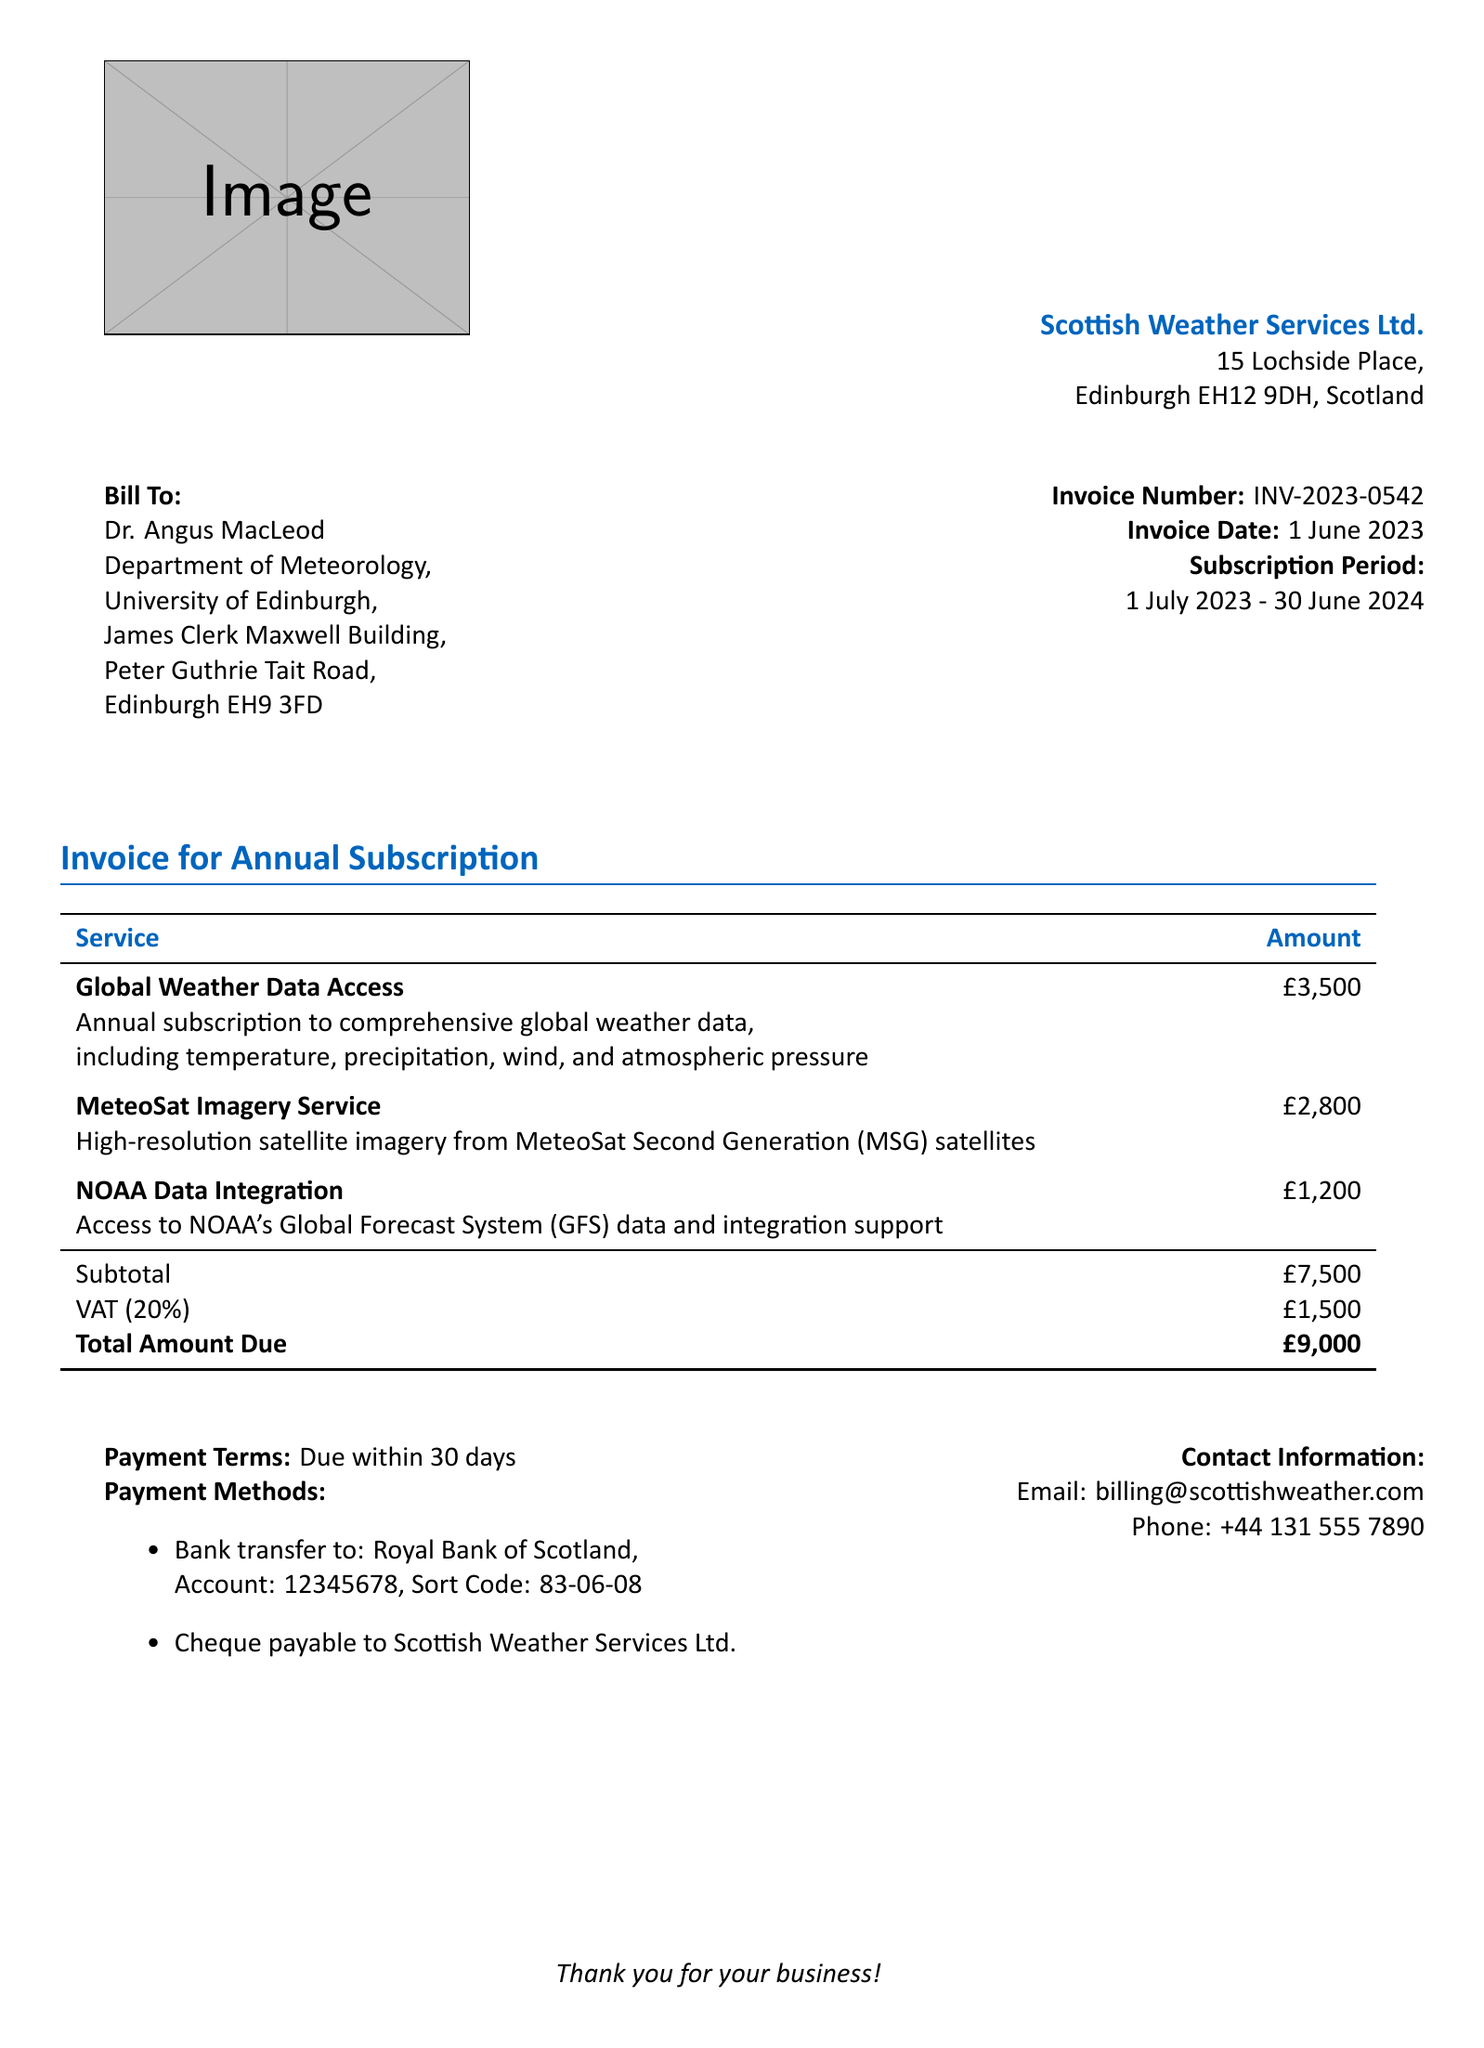What is the invoice number? The invoice number is a specific identifier for the bill, found in the document.
Answer: INV-2023-0542 Who is the bill addressed to? The bill lists the recipient's name and affiliation, which is crucial for invoicing.
Answer: Dr. Angus MacLeod What is the total amount due? This is the final charge that must be paid, including any taxes and fees, as indicated in the document.
Answer: £9,000 What is the VAT percentage? This percentage shows the value-added tax applied to the subtotal, necessary for understanding the total cost.
Answer: 20% What services are included in the annual subscription? This question helps to identify the specific services that the subscriber is paying for, which are listed in the document.
Answer: Global Weather Data Access, MeteoSat Imagery Service, NOAA Data Integration When is the payment due? The payment terms provide information on when the payment must be completed, which is essential for fiscal planning.
Answer: 30 days What is the subtotal amount before VAT? This is the total cost of services before tax is added, reflecting the base price for the subscription.
Answer: £7,500 What are the payment methods? Knowing the payment methods is essential for processing the payment, as the document outlines various options.
Answer: Bank transfer, Cheque Where is Scottish Weather Services Ltd. located? The address of the service provider gives insight into its geographical location which may be relevant for billing purposes.
Answer: 15 Lochside Place, Edinburgh EH12 9DH, Scotland 